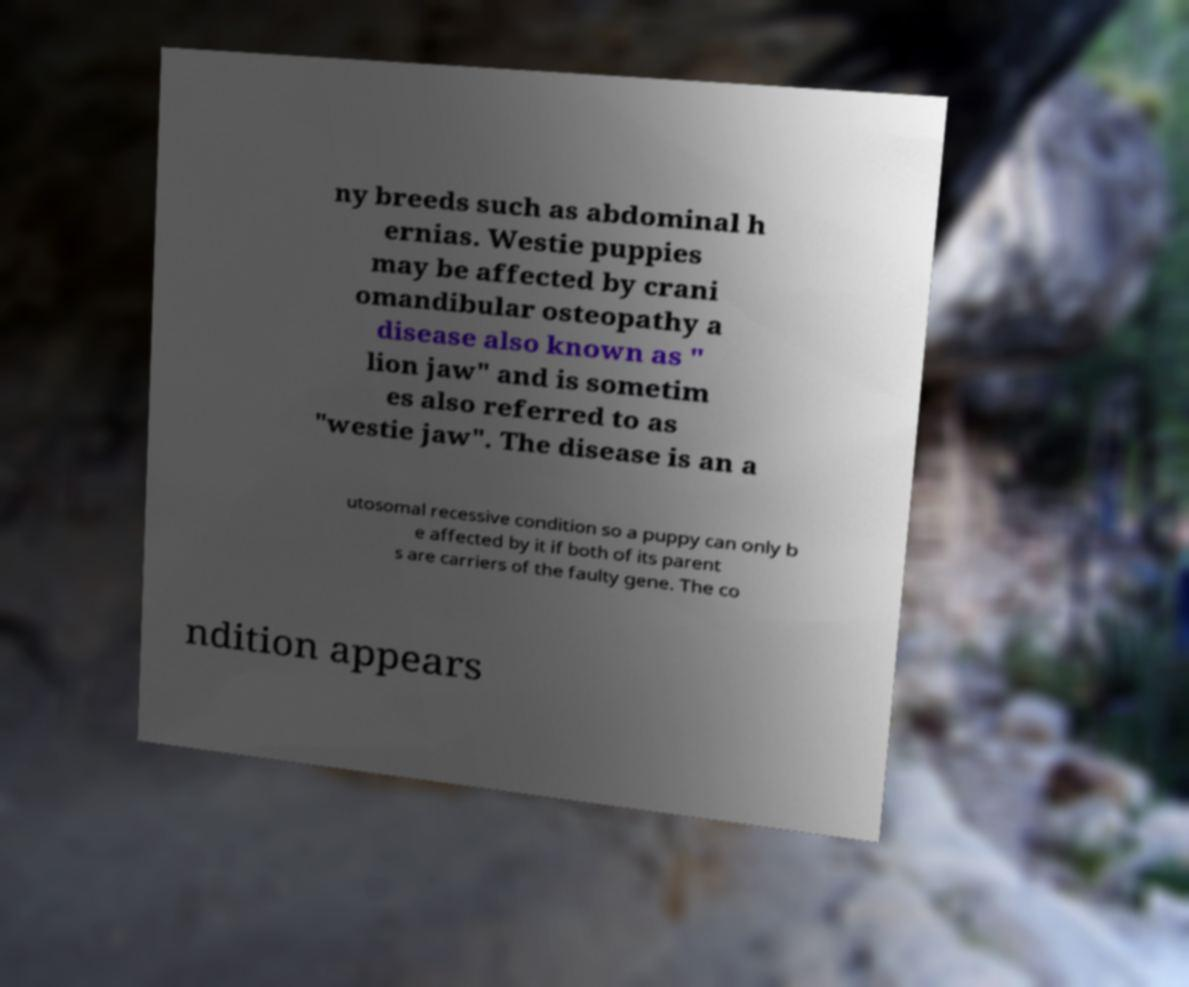Please identify and transcribe the text found in this image. ny breeds such as abdominal h ernias. Westie puppies may be affected by crani omandibular osteopathy a disease also known as " lion jaw" and is sometim es also referred to as "westie jaw". The disease is an a utosomal recessive condition so a puppy can only b e affected by it if both of its parent s are carriers of the faulty gene. The co ndition appears 